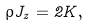Convert formula to latex. <formula><loc_0><loc_0><loc_500><loc_500>\rho J _ { z } = 2 K ,</formula> 